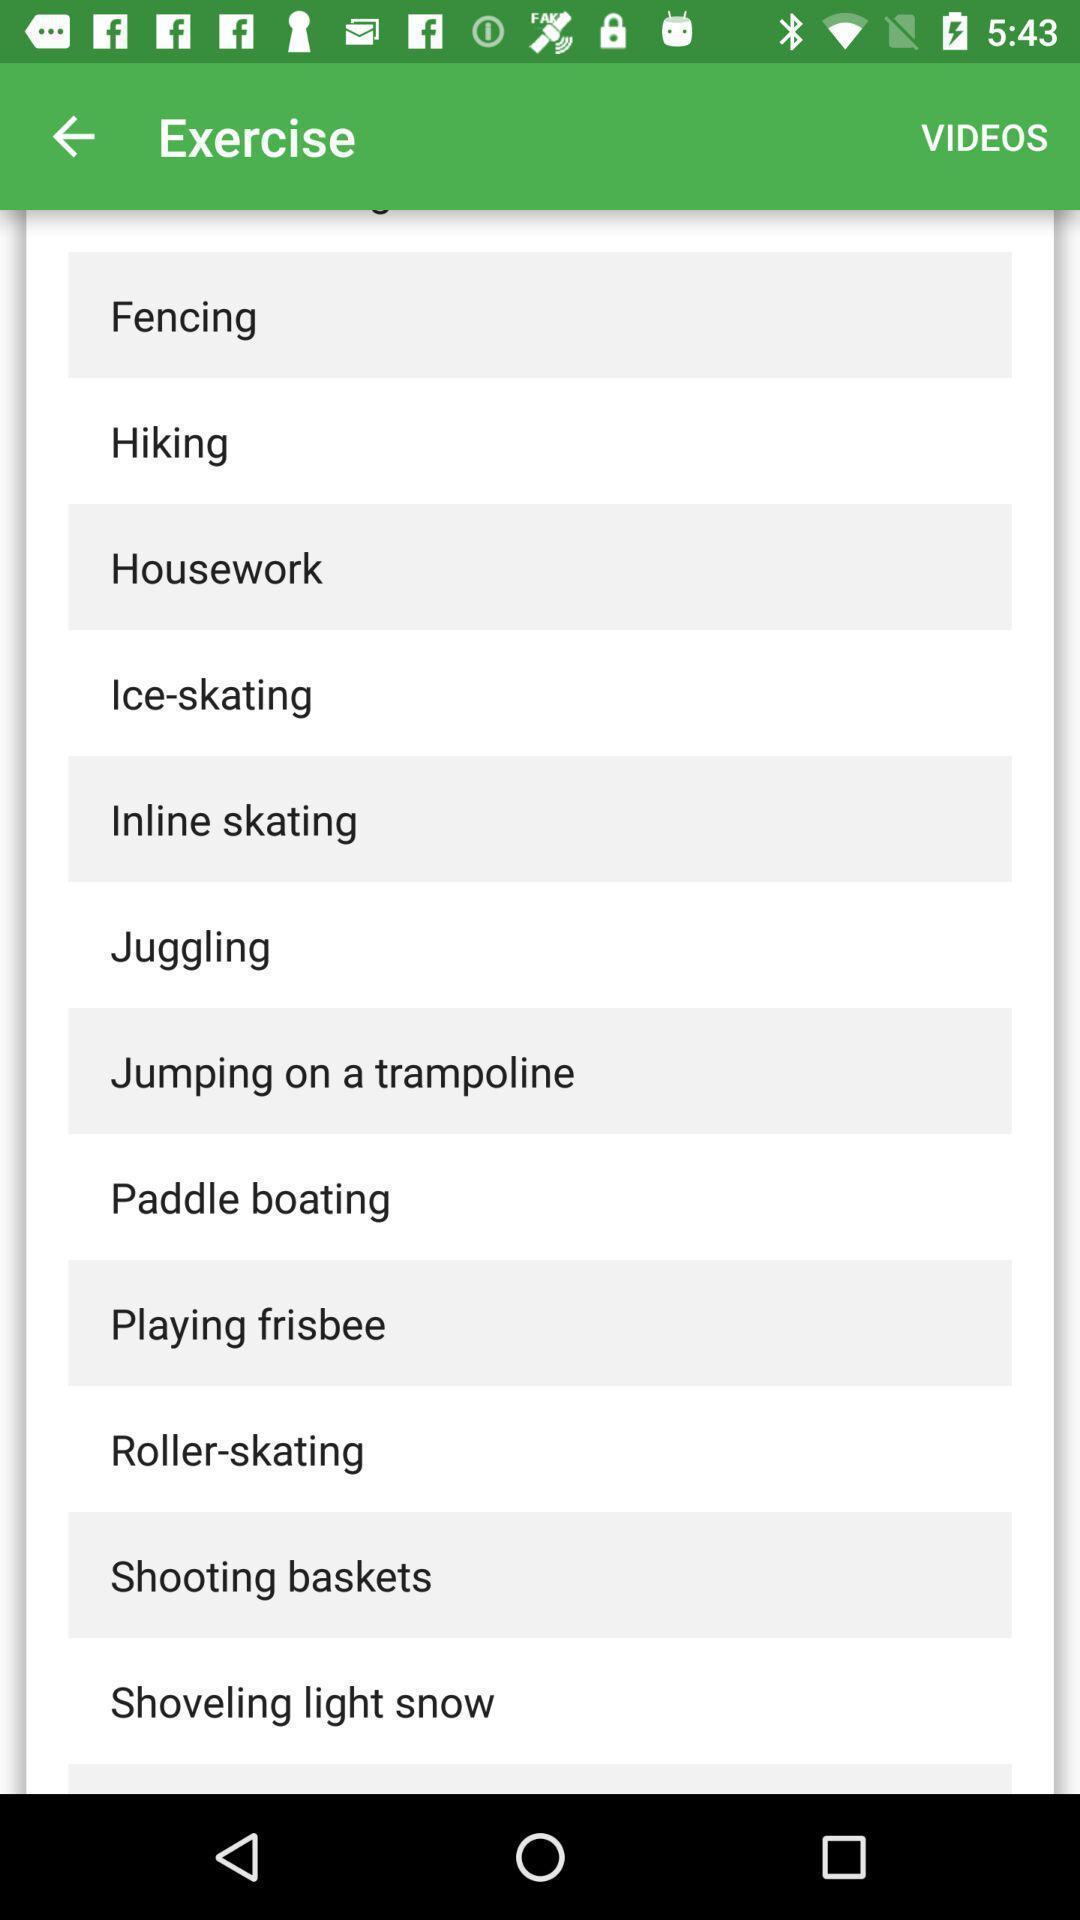Explain the elements present in this screenshot. Screen shows multiple options of fitness application. 